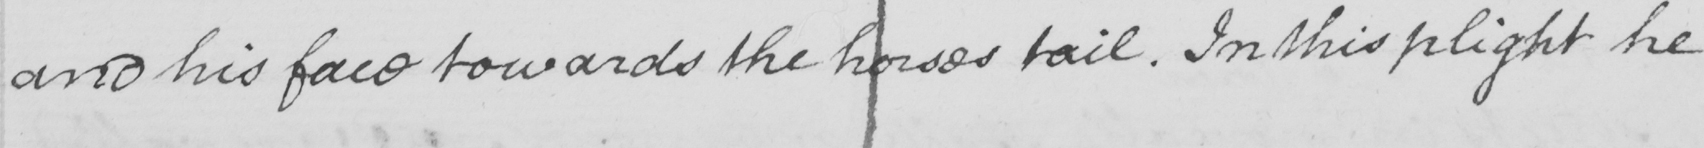Please provide the text content of this handwritten line. and his face towards the horses tail . In this plight he 